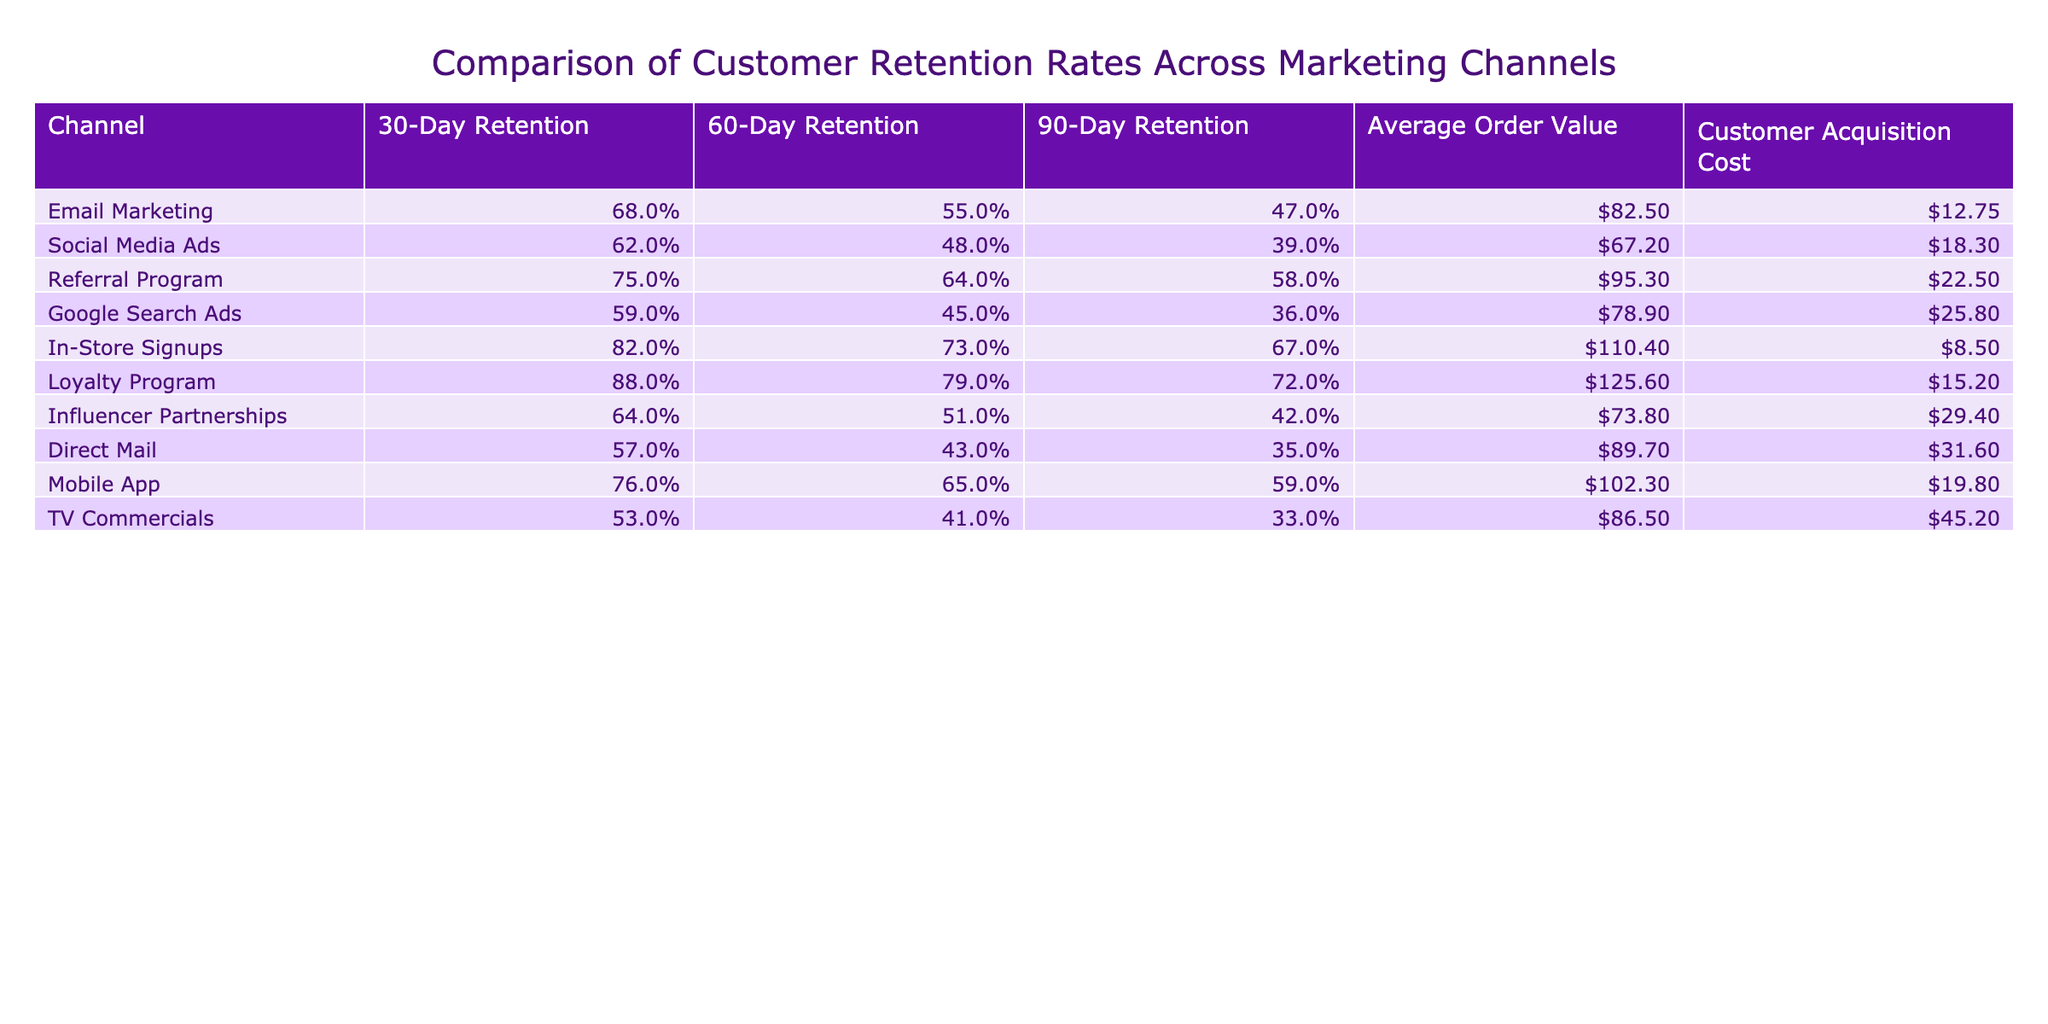What is the 30-day retention rate for the Loyalty Program? The table shows that the 30-day retention rate for the Loyalty Program is listed as 88%.
Answer: 88% Which marketing channel has the lowest 60-day retention rate? By comparing the 60-day retention columns across all channels, the channel with the lowest retention rate is the TV Commercials at 41%.
Answer: TV Commercials What is the difference in 90-day retention between the Referral Program and the Email Marketing? The Referral Program has a 90-day retention rate of 58%, while Email Marketing has 47%. The difference is 58% - 47% = 11%.
Answer: 11% Does In-Store Signups have a higher 30-day retention rate than Mobile App? The 30-day retention rate for In-Store Signups is 82%, while for Mobile App it is 76%. Since 82% is higher than 76%, the answer is yes.
Answer: Yes What is the average order value for Social Media Ads and what is the retention rate difference at 30 days compared to the Loyalty Program? The average order value for Social Media Ads is $67.20. The 30-day retention for Social Media Ads is 62%, while for Loyalty Program it is 88%. The difference in retention is 88% - 62% = 26%.
Answer: $67.20, 26% What is the average customer acquisition cost across all marketing channels? Adding the customer acquisition costs: $12.75 + $18.30 + $22.50 + $25.80 + $8.50 + $15.20 + $29.40 + $31.60 + $19.80 + $45.20 = $253.55. Dividing by the number of channels (10), gives an average of $25.36.
Answer: $25.36 Which channel shows the highest 60-day retention rate? The table indicates that the highest 60-day retention rate is for the Loyalty Program at 79%.
Answer: Loyalty Program Is the customer acquisition cost for the Mobile App lower than that of Email Marketing? The customer acquisition cost for Mobile App is $19.80 and for Email Marketing is $12.75. Since $19.80 is greater than $12.75, the answer is no.
Answer: No 